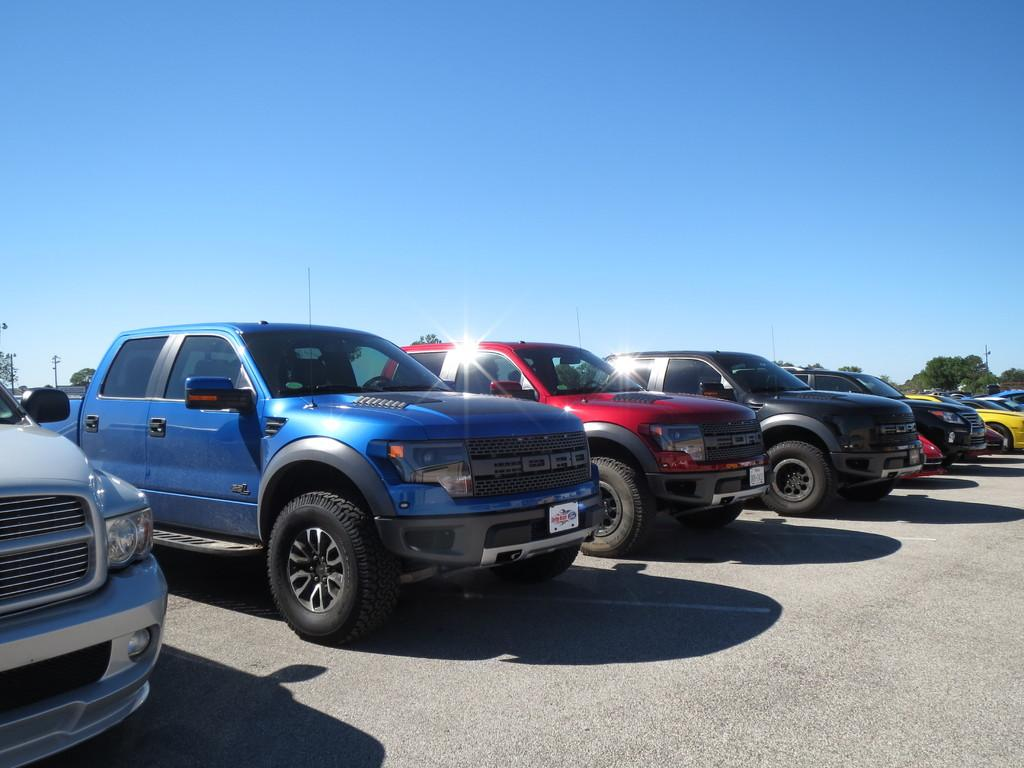Where was the image taken? The image was taken on a road. What can be seen on the road in the image? There are many cars parked on the road in the image. What is visible in the background of the image? There are trees and poles in the background of the image. What is visible at the top of the image? The sky is visible at the top of the image. Can you see any trampoline development in the image? There is no trampoline or development related to trampolines present in the image. What type of berry is growing on the trees in the image? There are no berries visible on the trees in the image; only the trees themselves can be seen. 